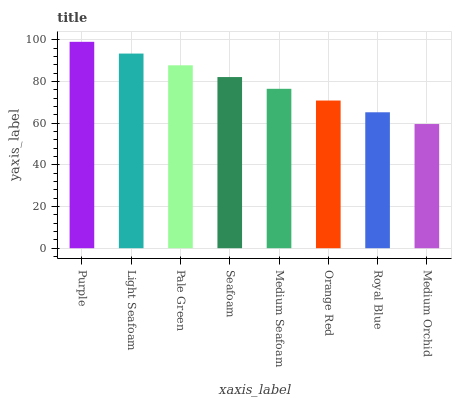Is Medium Orchid the minimum?
Answer yes or no. Yes. Is Purple the maximum?
Answer yes or no. Yes. Is Light Seafoam the minimum?
Answer yes or no. No. Is Light Seafoam the maximum?
Answer yes or no. No. Is Purple greater than Light Seafoam?
Answer yes or no. Yes. Is Light Seafoam less than Purple?
Answer yes or no. Yes. Is Light Seafoam greater than Purple?
Answer yes or no. No. Is Purple less than Light Seafoam?
Answer yes or no. No. Is Seafoam the high median?
Answer yes or no. Yes. Is Medium Seafoam the low median?
Answer yes or no. Yes. Is Medium Orchid the high median?
Answer yes or no. No. Is Royal Blue the low median?
Answer yes or no. No. 